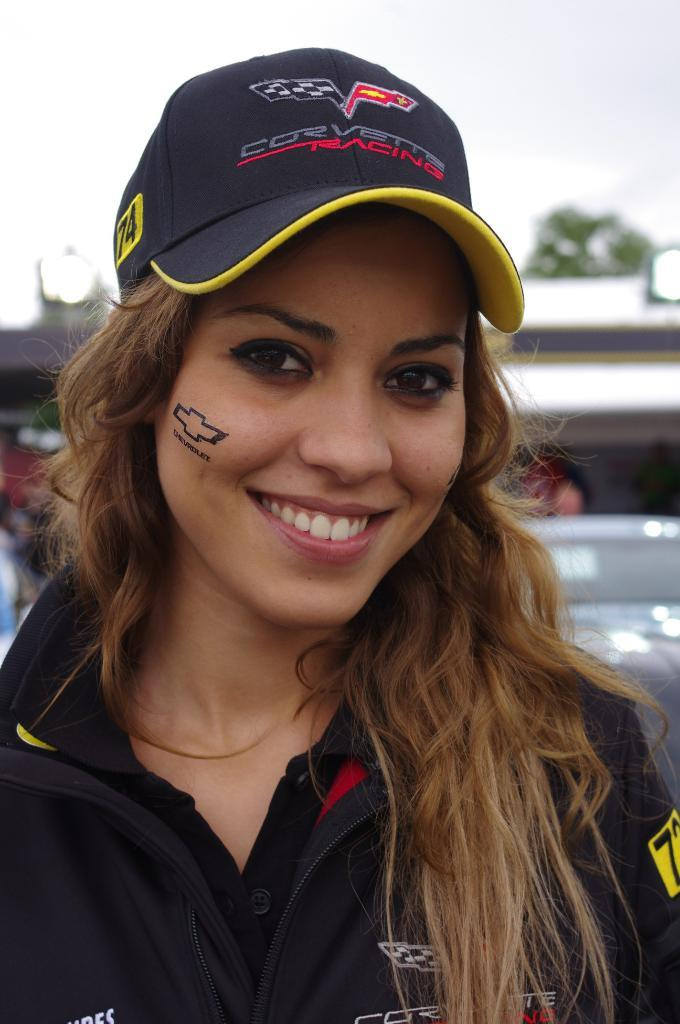Who is the main subject in the image? There is a woman in the image. What is the woman wearing on her upper body? The woman is wearing a blue T-shirt. What type of headwear is the woman wearing? The woman is wearing a black cap. What can be seen in the background of the image? There is a sky visible in the background of the image. What type of jar is the woman holding in the image? There is no jar present in the image; the woman is not holding any object. 